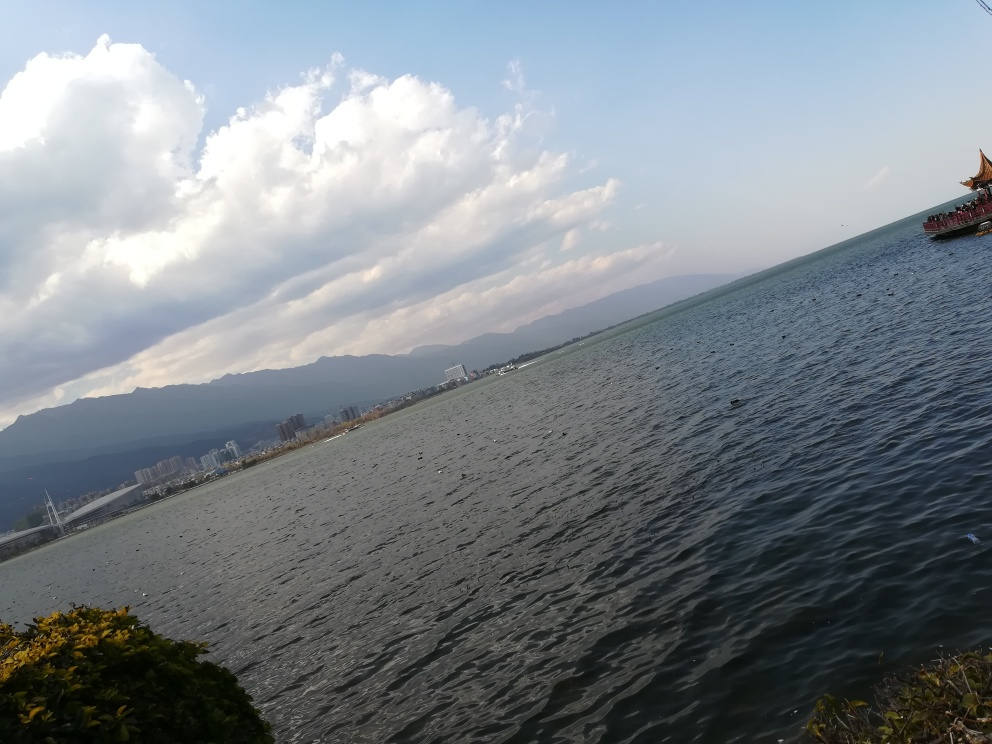What activities might be popular at this location? Given the presence of water and a boat, popular activities at this location could include boating, possibly fishing, and possibly lakeside picnics or walks, as indicated by the greenery at the water's edge. 